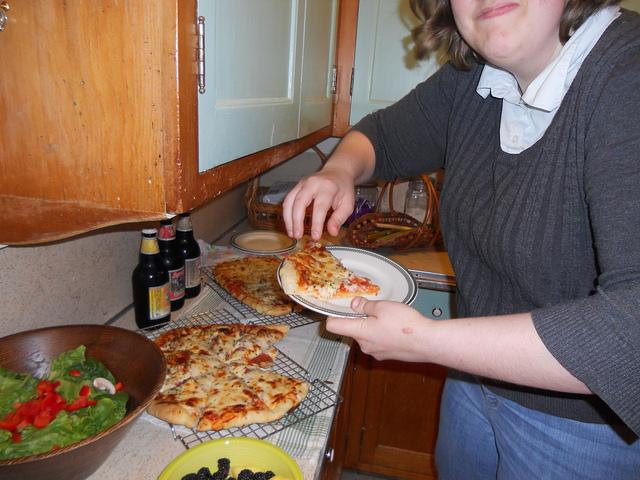What will the woman drink with her pizza? Please explain your reasoning. beer. A woman is eating pizza and bottles of beer are on the table in front of her. 